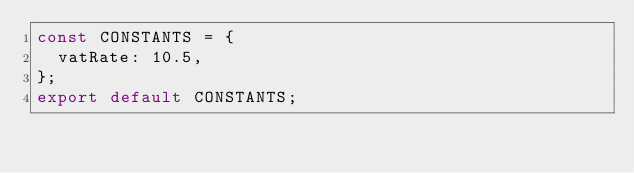Convert code to text. <code><loc_0><loc_0><loc_500><loc_500><_JavaScript_>const CONSTANTS = {
  vatRate: 10.5,
};
export default CONSTANTS;
</code> 